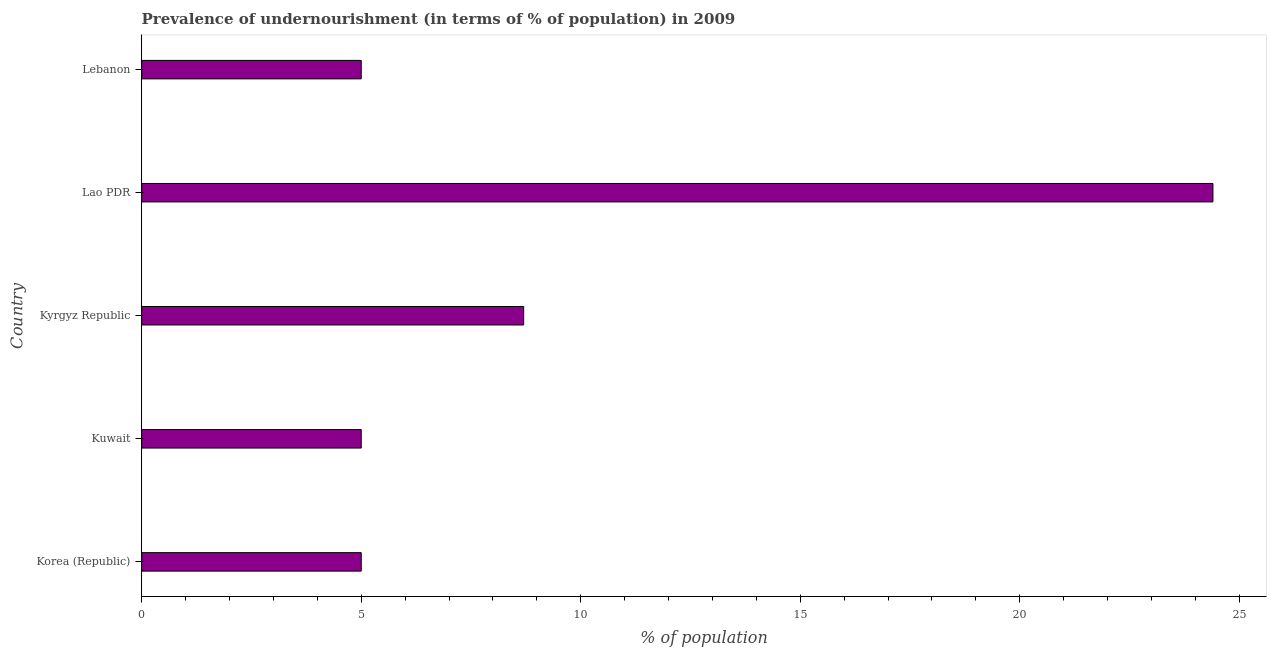What is the title of the graph?
Offer a terse response. Prevalence of undernourishment (in terms of % of population) in 2009. What is the label or title of the X-axis?
Keep it short and to the point. % of population. What is the percentage of undernourished population in Kyrgyz Republic?
Provide a short and direct response. 8.7. Across all countries, what is the maximum percentage of undernourished population?
Make the answer very short. 24.4. Across all countries, what is the minimum percentage of undernourished population?
Offer a very short reply. 5. In which country was the percentage of undernourished population maximum?
Ensure brevity in your answer.  Lao PDR. What is the sum of the percentage of undernourished population?
Your response must be concise. 48.1. What is the difference between the percentage of undernourished population in Lao PDR and Lebanon?
Offer a very short reply. 19.4. What is the average percentage of undernourished population per country?
Provide a short and direct response. 9.62. In how many countries, is the percentage of undernourished population greater than 10 %?
Keep it short and to the point. 1. What is the ratio of the percentage of undernourished population in Korea (Republic) to that in Lao PDR?
Provide a short and direct response. 0.2. Are all the bars in the graph horizontal?
Give a very brief answer. Yes. How many countries are there in the graph?
Your answer should be compact. 5. What is the % of population in Korea (Republic)?
Give a very brief answer. 5. What is the % of population of Lao PDR?
Keep it short and to the point. 24.4. What is the % of population of Lebanon?
Offer a very short reply. 5. What is the difference between the % of population in Korea (Republic) and Kyrgyz Republic?
Your answer should be compact. -3.7. What is the difference between the % of population in Korea (Republic) and Lao PDR?
Make the answer very short. -19.4. What is the difference between the % of population in Korea (Republic) and Lebanon?
Give a very brief answer. 0. What is the difference between the % of population in Kuwait and Lao PDR?
Your answer should be very brief. -19.4. What is the difference between the % of population in Kyrgyz Republic and Lao PDR?
Provide a succinct answer. -15.7. What is the difference between the % of population in Lao PDR and Lebanon?
Offer a terse response. 19.4. What is the ratio of the % of population in Korea (Republic) to that in Kuwait?
Give a very brief answer. 1. What is the ratio of the % of population in Korea (Republic) to that in Kyrgyz Republic?
Keep it short and to the point. 0.57. What is the ratio of the % of population in Korea (Republic) to that in Lao PDR?
Keep it short and to the point. 0.2. What is the ratio of the % of population in Korea (Republic) to that in Lebanon?
Provide a short and direct response. 1. What is the ratio of the % of population in Kuwait to that in Kyrgyz Republic?
Provide a succinct answer. 0.57. What is the ratio of the % of population in Kuwait to that in Lao PDR?
Offer a very short reply. 0.2. What is the ratio of the % of population in Kyrgyz Republic to that in Lao PDR?
Offer a terse response. 0.36. What is the ratio of the % of population in Kyrgyz Republic to that in Lebanon?
Give a very brief answer. 1.74. What is the ratio of the % of population in Lao PDR to that in Lebanon?
Ensure brevity in your answer.  4.88. 